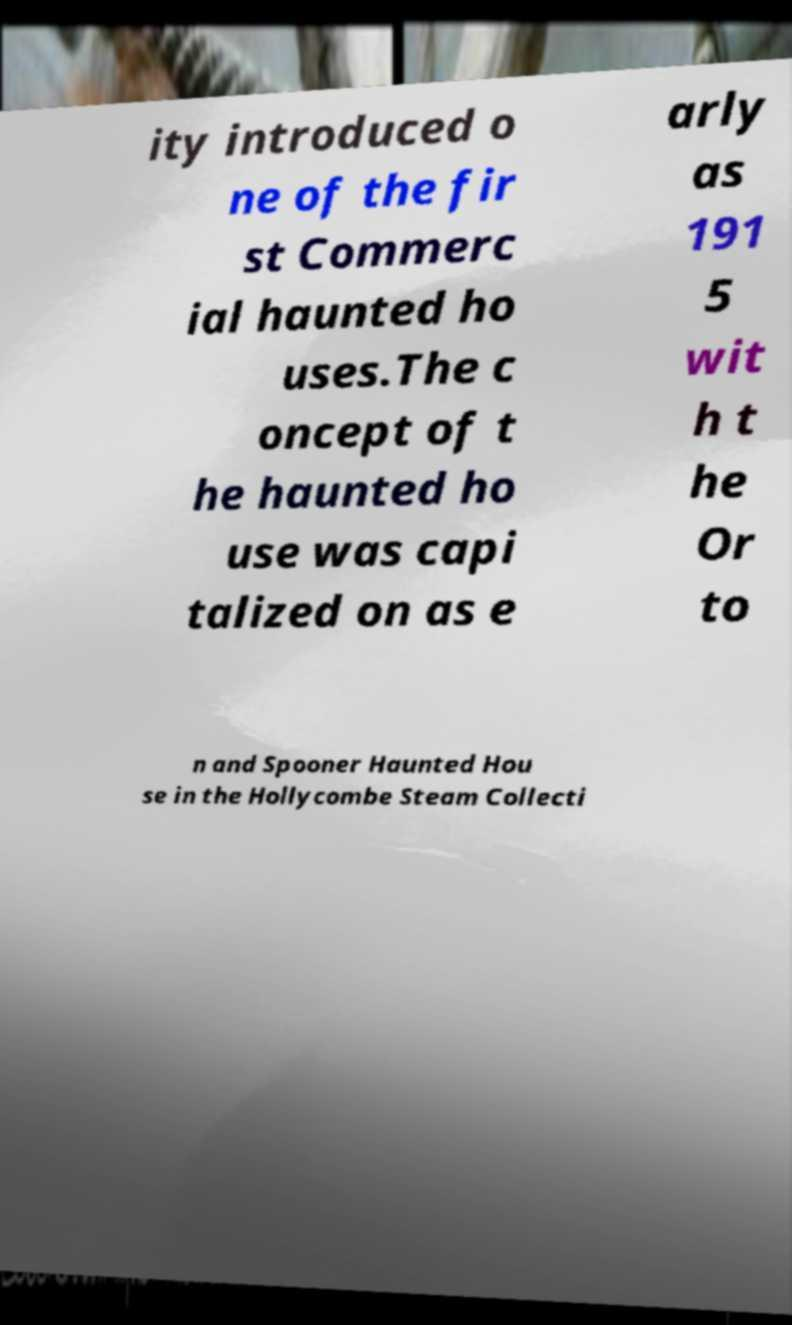Please read and relay the text visible in this image. What does it say? ity introduced o ne of the fir st Commerc ial haunted ho uses.The c oncept of t he haunted ho use was capi talized on as e arly as 191 5 wit h t he Or to n and Spooner Haunted Hou se in the Hollycombe Steam Collecti 